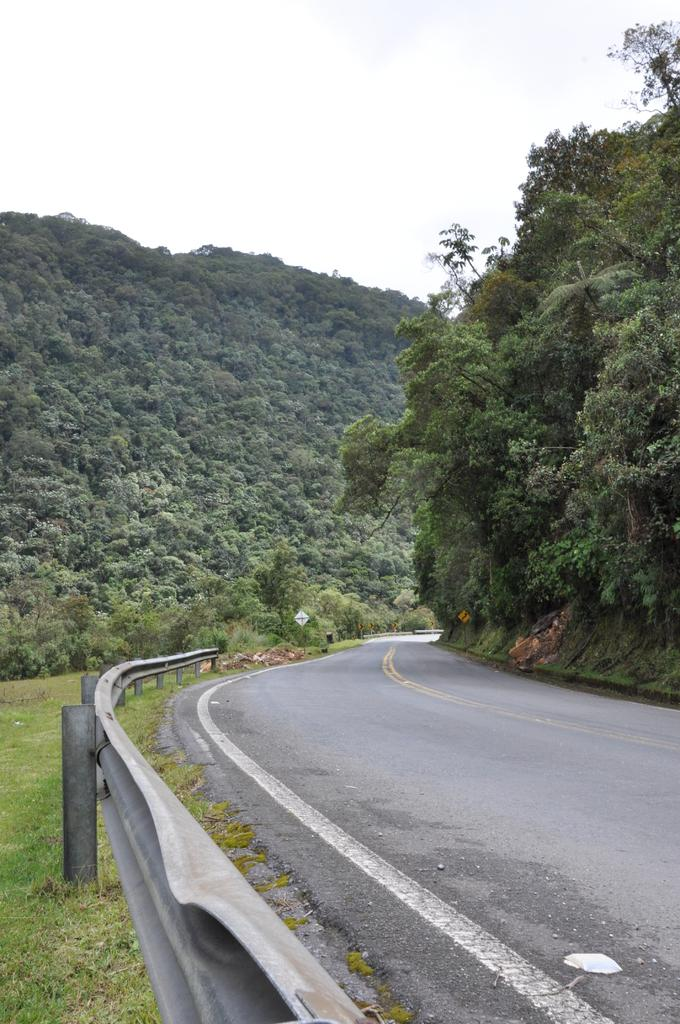What is located at the bottom of the image? There is a road, fencing, and grass at the bottom of the image. What can be seen in the middle of the image? There is a sign board, trees, and hills in the middle of the image. What is visible at the top of the image? The sky is visible at the top of the image. What type of education can be seen being provided in the image? There is no indication of education being provided in the image. Can you tell me where the camera is located in the image? There is no camera present in the image. 